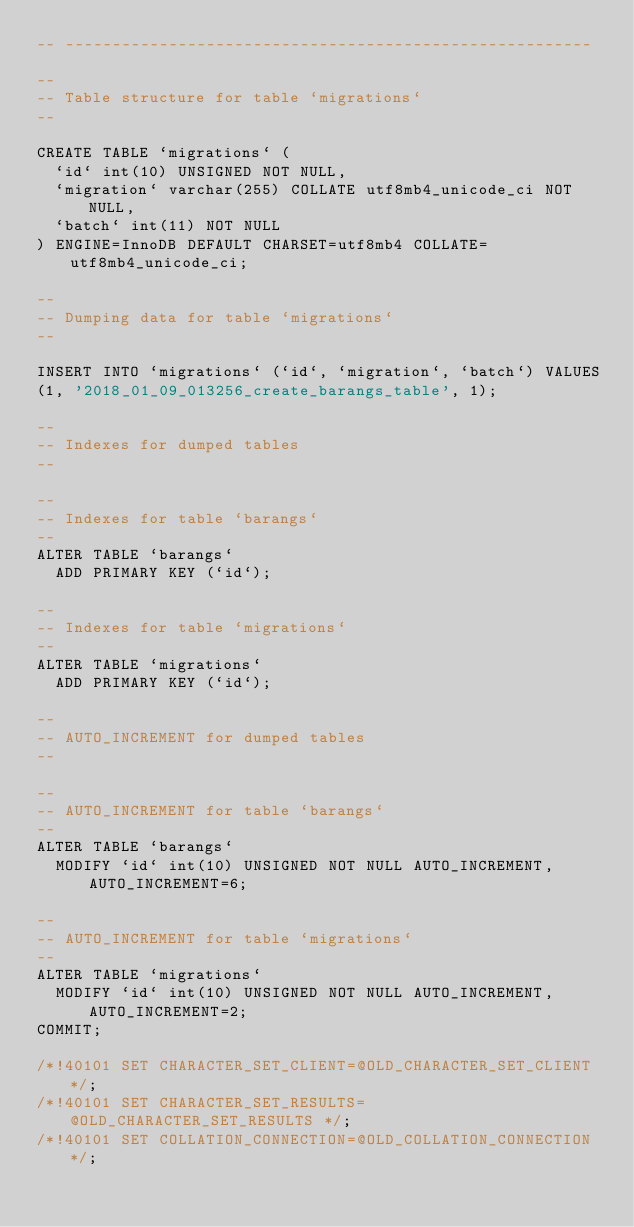<code> <loc_0><loc_0><loc_500><loc_500><_SQL_>-- --------------------------------------------------------

--
-- Table structure for table `migrations`
--

CREATE TABLE `migrations` (
  `id` int(10) UNSIGNED NOT NULL,
  `migration` varchar(255) COLLATE utf8mb4_unicode_ci NOT NULL,
  `batch` int(11) NOT NULL
) ENGINE=InnoDB DEFAULT CHARSET=utf8mb4 COLLATE=utf8mb4_unicode_ci;

--
-- Dumping data for table `migrations`
--

INSERT INTO `migrations` (`id`, `migration`, `batch`) VALUES
(1, '2018_01_09_013256_create_barangs_table', 1);

--
-- Indexes for dumped tables
--

--
-- Indexes for table `barangs`
--
ALTER TABLE `barangs`
  ADD PRIMARY KEY (`id`);

--
-- Indexes for table `migrations`
--
ALTER TABLE `migrations`
  ADD PRIMARY KEY (`id`);

--
-- AUTO_INCREMENT for dumped tables
--

--
-- AUTO_INCREMENT for table `barangs`
--
ALTER TABLE `barangs`
  MODIFY `id` int(10) UNSIGNED NOT NULL AUTO_INCREMENT, AUTO_INCREMENT=6;

--
-- AUTO_INCREMENT for table `migrations`
--
ALTER TABLE `migrations`
  MODIFY `id` int(10) UNSIGNED NOT NULL AUTO_INCREMENT, AUTO_INCREMENT=2;
COMMIT;

/*!40101 SET CHARACTER_SET_CLIENT=@OLD_CHARACTER_SET_CLIENT */;
/*!40101 SET CHARACTER_SET_RESULTS=@OLD_CHARACTER_SET_RESULTS */;
/*!40101 SET COLLATION_CONNECTION=@OLD_COLLATION_CONNECTION */;
</code> 